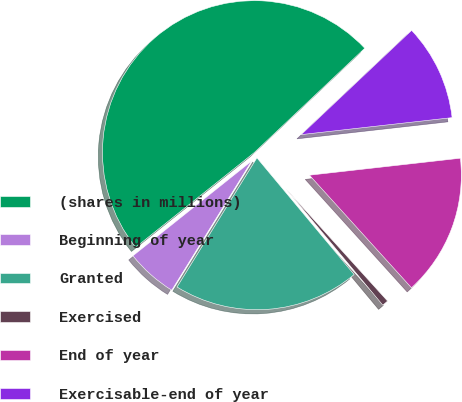<chart> <loc_0><loc_0><loc_500><loc_500><pie_chart><fcel>(shares in millions)<fcel>Beginning of year<fcel>Granted<fcel>Exercised<fcel>End of year<fcel>Exercisable-end of year<nl><fcel>48.68%<fcel>5.46%<fcel>19.87%<fcel>0.66%<fcel>15.07%<fcel>10.26%<nl></chart> 